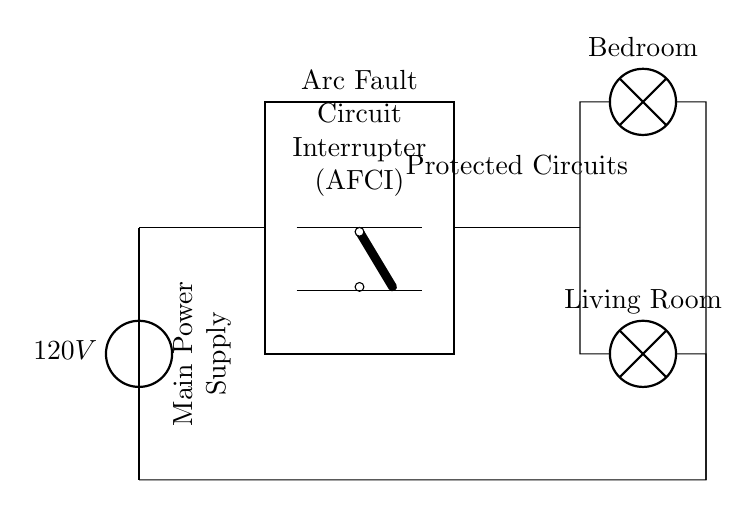What is the voltage of this circuit? The circuit has a main power supply that provides a voltage of 120 volts, as indicated by the voltage source label on the diagram.
Answer: 120 volts What component is used for protection in this circuit? The circuit specifically includes an Arc Fault Circuit Interrupter (AFCI), which is shown as a thick rectangle with the respective label in the diagram.
Answer: Arc Fault Circuit Interrupter How many rooms are connected to the AFCI? The diagram shows two lamps connected to the outputs of the AFCI: one for the bedroom and one for the living room, which indicates that there are two rooms connected.
Answer: Two rooms What type of switch is used in this circuit? A cute open switch is represented in the diagram, indicated by the symbol drawn near the AFCI, which allows or interrupts the circuit flow.
Answer: Cute open switch What is the purpose of an AFCI in this circuit? The AFCI is designed to provide protection against arc faults, which can lead to electrical fires, thus ensuring safety in the bedroom and living room circuits connected to it.
Answer: Protection against arc faults What is the direction of current flow from the AFCI? The current flows from the AFCI towards both the bedroom and living room lamps, as depicted by the lines extending from the AFCI output to the lamps.
Answer: Toward the lamps 